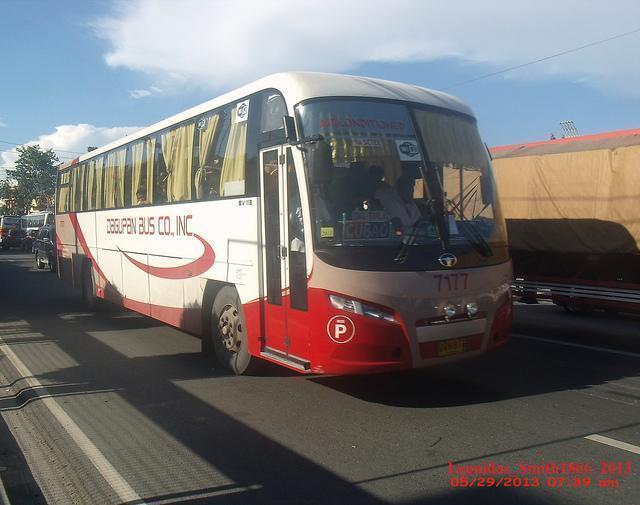Which street lane or lanes is the bus traveling in?
Choose the right answer and clarify with the format: 'Answer: answer
Rationale: rationale.'
Options: Left lane, both lanes, right lane, neither lane. Answer: both lanes.
Rationale: The bus is going in the middle of the lanes. 